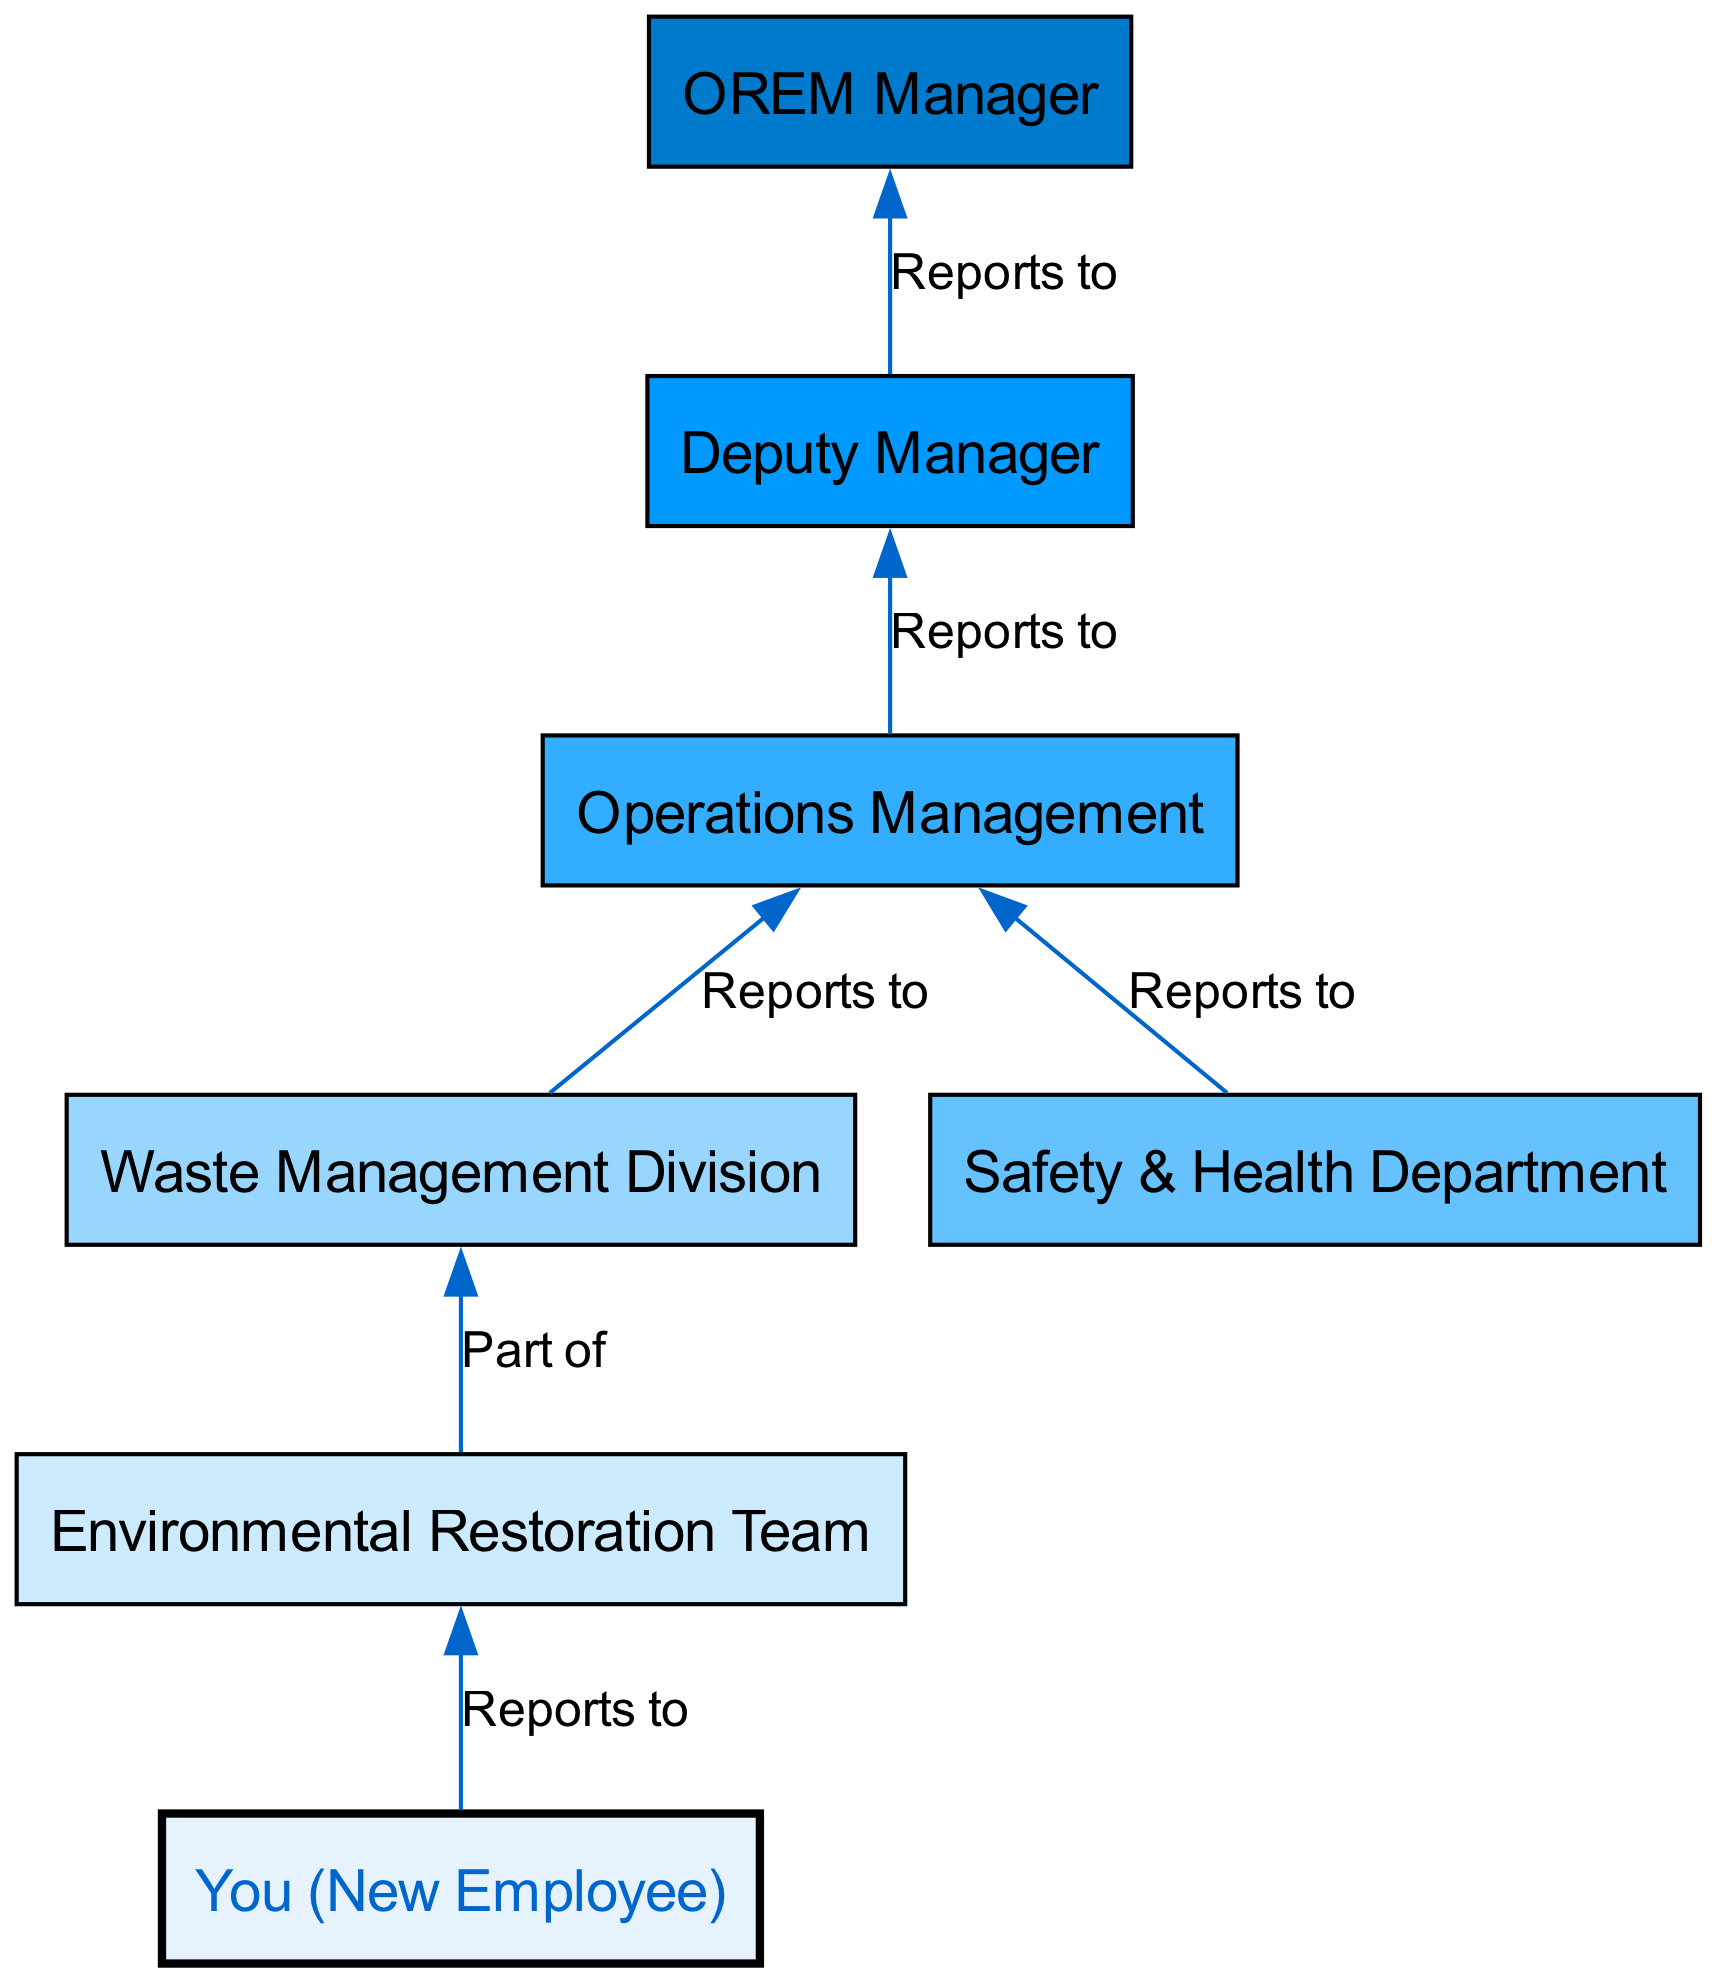What is the highest position in OREM's organizational structure? The diagram indicates that the highest position is held by the "OREM Manager," which is the top node in the flow chart.
Answer: OREM Manager How many total nodes are present in the diagram? By counting the nodes listed in the diagram, there are seven distinct nodes, representing different roles and teams within OREM.
Answer: 7 Who reports directly to the OREM Manager? The "Deputy Manager" is the only position directly below the OREM Manager in the hierarchy, as indicated by the edge connecting them.
Answer: Deputy Manager Which team does the new employee belong to? The diagram shows that the "New Employee" reports to the "Environmental Restoration Team," indicating their direct affiliation.
Answer: Environmental Restoration Team What department does the Waste Management Division report to? The "Waste Management Division" reports to the "Operations Management" as per the edge that connects these two nodes.
Answer: Operations Management What is the relationship between the Environmental Restoration Team and the Waste Management Division? The diagram states that the Environmental Restoration Team is part of the Waste Management Division, showing a hierarchical relationship where the team is a subset of the division.
Answer: Part of How many departments report to the Operations Management? There are two departments that report to Operations Management: the "Waste Management Division" and the "Safety & Health Department," as seen in the two edges connecting them.
Answer: 2 What is the main purpose of this Bottom Up Flow Chart? The purpose of this diagram is to represent the organizational structure from the operational teams up to leadership, illustrating reporting lines and relationships.
Answer: Organizational structure Which node is directly below the Safety & Health Department? The diagram does not directly indicate a node below "Safety & Health Department," but it shows that it connects to "Operations Management," so it indirectly continues upward to leadership.
Answer: Operations Management (indirectly) 